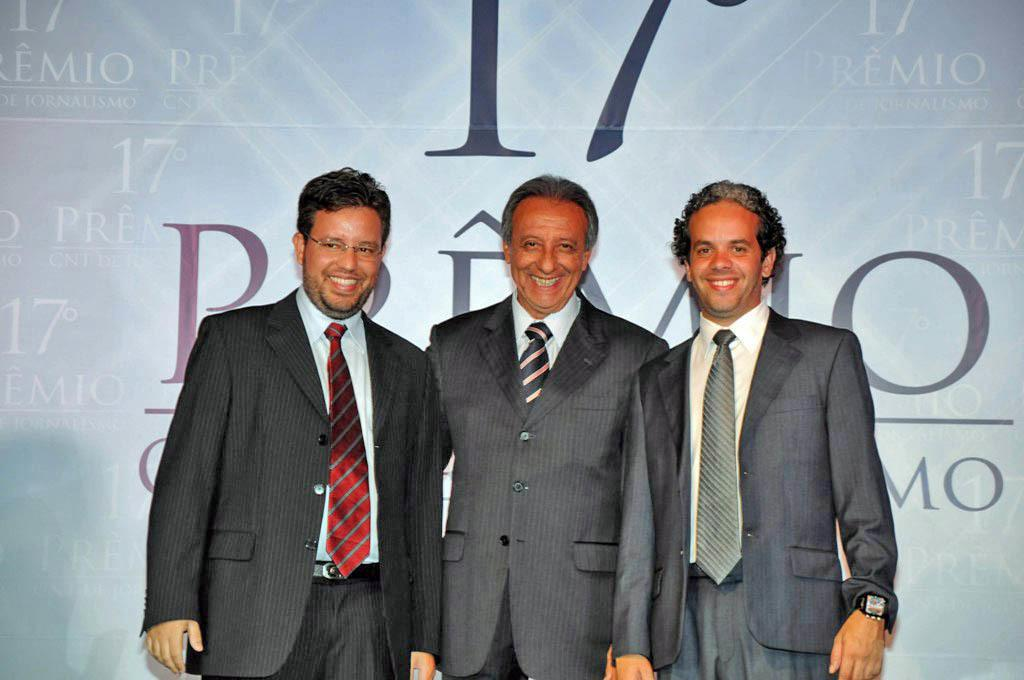How many people are in the image? There are three people in the image. What are the people doing in the image? The people are standing with smiles on their faces. What can be seen behind the people in the image? There is a banner with text behind the people. How many babies are crawling on the floor in the image? There are no babies present in the image; it features three people standing with smiles on their faces. What type of pot is visible on the table in the image? There is no pot visible in the image; it only shows three people standing with smiles on their faces and a banner with text behind them. 